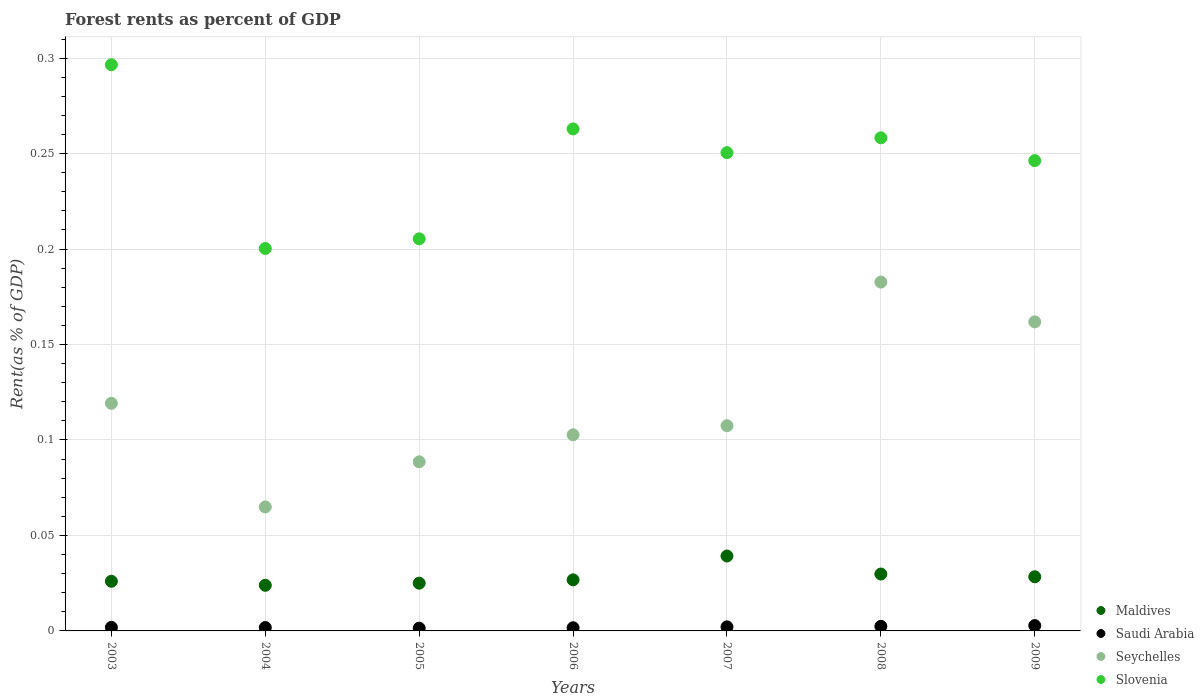How many different coloured dotlines are there?
Offer a terse response. 4. What is the forest rent in Maldives in 2009?
Give a very brief answer. 0.03. Across all years, what is the maximum forest rent in Maldives?
Your response must be concise. 0.04. Across all years, what is the minimum forest rent in Saudi Arabia?
Ensure brevity in your answer.  0. In which year was the forest rent in Saudi Arabia maximum?
Give a very brief answer. 2009. In which year was the forest rent in Slovenia minimum?
Your answer should be compact. 2004. What is the total forest rent in Slovenia in the graph?
Ensure brevity in your answer.  1.72. What is the difference between the forest rent in Seychelles in 2003 and that in 2007?
Provide a succinct answer. 0.01. What is the difference between the forest rent in Saudi Arabia in 2003 and the forest rent in Seychelles in 2008?
Offer a very short reply. -0.18. What is the average forest rent in Seychelles per year?
Your answer should be very brief. 0.12. In the year 2009, what is the difference between the forest rent in Saudi Arabia and forest rent in Slovenia?
Offer a terse response. -0.24. What is the ratio of the forest rent in Seychelles in 2003 to that in 2006?
Offer a very short reply. 1.16. Is the forest rent in Slovenia in 2003 less than that in 2009?
Give a very brief answer. No. Is the difference between the forest rent in Saudi Arabia in 2003 and 2008 greater than the difference between the forest rent in Slovenia in 2003 and 2008?
Give a very brief answer. No. What is the difference between the highest and the second highest forest rent in Seychelles?
Your response must be concise. 0.02. What is the difference between the highest and the lowest forest rent in Seychelles?
Ensure brevity in your answer.  0.12. In how many years, is the forest rent in Seychelles greater than the average forest rent in Seychelles taken over all years?
Provide a short and direct response. 3. Is it the case that in every year, the sum of the forest rent in Seychelles and forest rent in Saudi Arabia  is greater than the sum of forest rent in Slovenia and forest rent in Maldives?
Your answer should be very brief. No. Is it the case that in every year, the sum of the forest rent in Maldives and forest rent in Seychelles  is greater than the forest rent in Slovenia?
Your answer should be very brief. No. Is the forest rent in Saudi Arabia strictly greater than the forest rent in Seychelles over the years?
Give a very brief answer. No. Is the forest rent in Slovenia strictly less than the forest rent in Seychelles over the years?
Your answer should be very brief. No. Does the graph contain grids?
Provide a succinct answer. Yes. How many legend labels are there?
Offer a very short reply. 4. What is the title of the graph?
Give a very brief answer. Forest rents as percent of GDP. Does "Middle income" appear as one of the legend labels in the graph?
Keep it short and to the point. No. What is the label or title of the Y-axis?
Give a very brief answer. Rent(as % of GDP). What is the Rent(as % of GDP) in Maldives in 2003?
Keep it short and to the point. 0.03. What is the Rent(as % of GDP) in Saudi Arabia in 2003?
Your answer should be very brief. 0. What is the Rent(as % of GDP) in Seychelles in 2003?
Make the answer very short. 0.12. What is the Rent(as % of GDP) of Slovenia in 2003?
Give a very brief answer. 0.3. What is the Rent(as % of GDP) of Maldives in 2004?
Provide a succinct answer. 0.02. What is the Rent(as % of GDP) of Saudi Arabia in 2004?
Offer a terse response. 0. What is the Rent(as % of GDP) of Seychelles in 2004?
Offer a very short reply. 0.06. What is the Rent(as % of GDP) in Slovenia in 2004?
Ensure brevity in your answer.  0.2. What is the Rent(as % of GDP) in Maldives in 2005?
Your answer should be very brief. 0.03. What is the Rent(as % of GDP) in Saudi Arabia in 2005?
Keep it short and to the point. 0. What is the Rent(as % of GDP) in Seychelles in 2005?
Offer a terse response. 0.09. What is the Rent(as % of GDP) in Slovenia in 2005?
Offer a very short reply. 0.21. What is the Rent(as % of GDP) in Maldives in 2006?
Ensure brevity in your answer.  0.03. What is the Rent(as % of GDP) of Saudi Arabia in 2006?
Provide a short and direct response. 0. What is the Rent(as % of GDP) in Seychelles in 2006?
Offer a terse response. 0.1. What is the Rent(as % of GDP) in Slovenia in 2006?
Offer a very short reply. 0.26. What is the Rent(as % of GDP) in Maldives in 2007?
Your answer should be very brief. 0.04. What is the Rent(as % of GDP) of Saudi Arabia in 2007?
Provide a short and direct response. 0. What is the Rent(as % of GDP) in Seychelles in 2007?
Provide a succinct answer. 0.11. What is the Rent(as % of GDP) in Slovenia in 2007?
Give a very brief answer. 0.25. What is the Rent(as % of GDP) in Maldives in 2008?
Offer a terse response. 0.03. What is the Rent(as % of GDP) in Saudi Arabia in 2008?
Provide a short and direct response. 0. What is the Rent(as % of GDP) of Seychelles in 2008?
Give a very brief answer. 0.18. What is the Rent(as % of GDP) in Slovenia in 2008?
Offer a very short reply. 0.26. What is the Rent(as % of GDP) of Maldives in 2009?
Make the answer very short. 0.03. What is the Rent(as % of GDP) in Saudi Arabia in 2009?
Your response must be concise. 0. What is the Rent(as % of GDP) in Seychelles in 2009?
Offer a very short reply. 0.16. What is the Rent(as % of GDP) in Slovenia in 2009?
Your answer should be very brief. 0.25. Across all years, what is the maximum Rent(as % of GDP) in Maldives?
Keep it short and to the point. 0.04. Across all years, what is the maximum Rent(as % of GDP) in Saudi Arabia?
Your answer should be compact. 0. Across all years, what is the maximum Rent(as % of GDP) of Seychelles?
Provide a succinct answer. 0.18. Across all years, what is the maximum Rent(as % of GDP) in Slovenia?
Your answer should be very brief. 0.3. Across all years, what is the minimum Rent(as % of GDP) of Maldives?
Provide a succinct answer. 0.02. Across all years, what is the minimum Rent(as % of GDP) in Saudi Arabia?
Offer a very short reply. 0. Across all years, what is the minimum Rent(as % of GDP) in Seychelles?
Your response must be concise. 0.06. Across all years, what is the minimum Rent(as % of GDP) in Slovenia?
Give a very brief answer. 0.2. What is the total Rent(as % of GDP) of Maldives in the graph?
Ensure brevity in your answer.  0.2. What is the total Rent(as % of GDP) in Saudi Arabia in the graph?
Provide a short and direct response. 0.01. What is the total Rent(as % of GDP) in Seychelles in the graph?
Make the answer very short. 0.83. What is the total Rent(as % of GDP) of Slovenia in the graph?
Provide a succinct answer. 1.72. What is the difference between the Rent(as % of GDP) of Maldives in 2003 and that in 2004?
Your response must be concise. 0. What is the difference between the Rent(as % of GDP) of Seychelles in 2003 and that in 2004?
Give a very brief answer. 0.05. What is the difference between the Rent(as % of GDP) in Slovenia in 2003 and that in 2004?
Provide a succinct answer. 0.1. What is the difference between the Rent(as % of GDP) of Maldives in 2003 and that in 2005?
Provide a succinct answer. 0. What is the difference between the Rent(as % of GDP) of Saudi Arabia in 2003 and that in 2005?
Provide a short and direct response. 0. What is the difference between the Rent(as % of GDP) of Seychelles in 2003 and that in 2005?
Offer a terse response. 0.03. What is the difference between the Rent(as % of GDP) in Slovenia in 2003 and that in 2005?
Offer a very short reply. 0.09. What is the difference between the Rent(as % of GDP) in Maldives in 2003 and that in 2006?
Give a very brief answer. -0. What is the difference between the Rent(as % of GDP) of Seychelles in 2003 and that in 2006?
Your answer should be compact. 0.02. What is the difference between the Rent(as % of GDP) in Slovenia in 2003 and that in 2006?
Provide a succinct answer. 0.03. What is the difference between the Rent(as % of GDP) of Maldives in 2003 and that in 2007?
Give a very brief answer. -0.01. What is the difference between the Rent(as % of GDP) of Saudi Arabia in 2003 and that in 2007?
Offer a very short reply. -0. What is the difference between the Rent(as % of GDP) of Seychelles in 2003 and that in 2007?
Keep it short and to the point. 0.01. What is the difference between the Rent(as % of GDP) in Slovenia in 2003 and that in 2007?
Offer a very short reply. 0.05. What is the difference between the Rent(as % of GDP) in Maldives in 2003 and that in 2008?
Provide a short and direct response. -0. What is the difference between the Rent(as % of GDP) in Saudi Arabia in 2003 and that in 2008?
Keep it short and to the point. -0. What is the difference between the Rent(as % of GDP) of Seychelles in 2003 and that in 2008?
Offer a terse response. -0.06. What is the difference between the Rent(as % of GDP) in Slovenia in 2003 and that in 2008?
Ensure brevity in your answer.  0.04. What is the difference between the Rent(as % of GDP) in Maldives in 2003 and that in 2009?
Your answer should be compact. -0. What is the difference between the Rent(as % of GDP) in Saudi Arabia in 2003 and that in 2009?
Your response must be concise. -0. What is the difference between the Rent(as % of GDP) in Seychelles in 2003 and that in 2009?
Ensure brevity in your answer.  -0.04. What is the difference between the Rent(as % of GDP) of Slovenia in 2003 and that in 2009?
Offer a very short reply. 0.05. What is the difference between the Rent(as % of GDP) in Maldives in 2004 and that in 2005?
Offer a very short reply. -0. What is the difference between the Rent(as % of GDP) in Saudi Arabia in 2004 and that in 2005?
Offer a terse response. 0. What is the difference between the Rent(as % of GDP) in Seychelles in 2004 and that in 2005?
Your response must be concise. -0.02. What is the difference between the Rent(as % of GDP) in Slovenia in 2004 and that in 2005?
Ensure brevity in your answer.  -0.01. What is the difference between the Rent(as % of GDP) in Maldives in 2004 and that in 2006?
Offer a very short reply. -0. What is the difference between the Rent(as % of GDP) in Seychelles in 2004 and that in 2006?
Provide a short and direct response. -0.04. What is the difference between the Rent(as % of GDP) in Slovenia in 2004 and that in 2006?
Make the answer very short. -0.06. What is the difference between the Rent(as % of GDP) of Maldives in 2004 and that in 2007?
Keep it short and to the point. -0.02. What is the difference between the Rent(as % of GDP) in Saudi Arabia in 2004 and that in 2007?
Your answer should be compact. -0. What is the difference between the Rent(as % of GDP) of Seychelles in 2004 and that in 2007?
Keep it short and to the point. -0.04. What is the difference between the Rent(as % of GDP) of Slovenia in 2004 and that in 2007?
Your response must be concise. -0.05. What is the difference between the Rent(as % of GDP) in Maldives in 2004 and that in 2008?
Your answer should be compact. -0.01. What is the difference between the Rent(as % of GDP) in Saudi Arabia in 2004 and that in 2008?
Give a very brief answer. -0. What is the difference between the Rent(as % of GDP) of Seychelles in 2004 and that in 2008?
Your answer should be very brief. -0.12. What is the difference between the Rent(as % of GDP) of Slovenia in 2004 and that in 2008?
Your answer should be compact. -0.06. What is the difference between the Rent(as % of GDP) of Maldives in 2004 and that in 2009?
Make the answer very short. -0. What is the difference between the Rent(as % of GDP) of Saudi Arabia in 2004 and that in 2009?
Keep it short and to the point. -0. What is the difference between the Rent(as % of GDP) of Seychelles in 2004 and that in 2009?
Provide a short and direct response. -0.1. What is the difference between the Rent(as % of GDP) in Slovenia in 2004 and that in 2009?
Your answer should be compact. -0.05. What is the difference between the Rent(as % of GDP) of Maldives in 2005 and that in 2006?
Offer a terse response. -0. What is the difference between the Rent(as % of GDP) in Saudi Arabia in 2005 and that in 2006?
Provide a short and direct response. -0. What is the difference between the Rent(as % of GDP) in Seychelles in 2005 and that in 2006?
Provide a short and direct response. -0.01. What is the difference between the Rent(as % of GDP) of Slovenia in 2005 and that in 2006?
Ensure brevity in your answer.  -0.06. What is the difference between the Rent(as % of GDP) of Maldives in 2005 and that in 2007?
Your answer should be very brief. -0.01. What is the difference between the Rent(as % of GDP) in Saudi Arabia in 2005 and that in 2007?
Give a very brief answer. -0. What is the difference between the Rent(as % of GDP) of Seychelles in 2005 and that in 2007?
Provide a succinct answer. -0.02. What is the difference between the Rent(as % of GDP) in Slovenia in 2005 and that in 2007?
Offer a very short reply. -0.05. What is the difference between the Rent(as % of GDP) of Maldives in 2005 and that in 2008?
Give a very brief answer. -0. What is the difference between the Rent(as % of GDP) of Saudi Arabia in 2005 and that in 2008?
Offer a very short reply. -0. What is the difference between the Rent(as % of GDP) in Seychelles in 2005 and that in 2008?
Offer a very short reply. -0.09. What is the difference between the Rent(as % of GDP) in Slovenia in 2005 and that in 2008?
Give a very brief answer. -0.05. What is the difference between the Rent(as % of GDP) in Maldives in 2005 and that in 2009?
Make the answer very short. -0. What is the difference between the Rent(as % of GDP) in Saudi Arabia in 2005 and that in 2009?
Offer a terse response. -0. What is the difference between the Rent(as % of GDP) in Seychelles in 2005 and that in 2009?
Your answer should be compact. -0.07. What is the difference between the Rent(as % of GDP) of Slovenia in 2005 and that in 2009?
Keep it short and to the point. -0.04. What is the difference between the Rent(as % of GDP) in Maldives in 2006 and that in 2007?
Make the answer very short. -0.01. What is the difference between the Rent(as % of GDP) of Saudi Arabia in 2006 and that in 2007?
Make the answer very short. -0. What is the difference between the Rent(as % of GDP) of Seychelles in 2006 and that in 2007?
Make the answer very short. -0. What is the difference between the Rent(as % of GDP) of Slovenia in 2006 and that in 2007?
Give a very brief answer. 0.01. What is the difference between the Rent(as % of GDP) in Maldives in 2006 and that in 2008?
Your response must be concise. -0. What is the difference between the Rent(as % of GDP) in Saudi Arabia in 2006 and that in 2008?
Provide a succinct answer. -0. What is the difference between the Rent(as % of GDP) in Seychelles in 2006 and that in 2008?
Keep it short and to the point. -0.08. What is the difference between the Rent(as % of GDP) of Slovenia in 2006 and that in 2008?
Offer a terse response. 0. What is the difference between the Rent(as % of GDP) of Maldives in 2006 and that in 2009?
Offer a very short reply. -0. What is the difference between the Rent(as % of GDP) of Saudi Arabia in 2006 and that in 2009?
Give a very brief answer. -0. What is the difference between the Rent(as % of GDP) in Seychelles in 2006 and that in 2009?
Make the answer very short. -0.06. What is the difference between the Rent(as % of GDP) in Slovenia in 2006 and that in 2009?
Offer a terse response. 0.02. What is the difference between the Rent(as % of GDP) of Maldives in 2007 and that in 2008?
Provide a short and direct response. 0.01. What is the difference between the Rent(as % of GDP) in Saudi Arabia in 2007 and that in 2008?
Your answer should be compact. -0. What is the difference between the Rent(as % of GDP) in Seychelles in 2007 and that in 2008?
Give a very brief answer. -0.08. What is the difference between the Rent(as % of GDP) of Slovenia in 2007 and that in 2008?
Provide a short and direct response. -0.01. What is the difference between the Rent(as % of GDP) in Maldives in 2007 and that in 2009?
Make the answer very short. 0.01. What is the difference between the Rent(as % of GDP) in Saudi Arabia in 2007 and that in 2009?
Ensure brevity in your answer.  -0. What is the difference between the Rent(as % of GDP) in Seychelles in 2007 and that in 2009?
Offer a very short reply. -0.05. What is the difference between the Rent(as % of GDP) of Slovenia in 2007 and that in 2009?
Provide a succinct answer. 0. What is the difference between the Rent(as % of GDP) of Maldives in 2008 and that in 2009?
Ensure brevity in your answer.  0. What is the difference between the Rent(as % of GDP) of Saudi Arabia in 2008 and that in 2009?
Provide a succinct answer. -0. What is the difference between the Rent(as % of GDP) of Seychelles in 2008 and that in 2009?
Offer a terse response. 0.02. What is the difference between the Rent(as % of GDP) in Slovenia in 2008 and that in 2009?
Your answer should be compact. 0.01. What is the difference between the Rent(as % of GDP) of Maldives in 2003 and the Rent(as % of GDP) of Saudi Arabia in 2004?
Provide a short and direct response. 0.02. What is the difference between the Rent(as % of GDP) in Maldives in 2003 and the Rent(as % of GDP) in Seychelles in 2004?
Provide a short and direct response. -0.04. What is the difference between the Rent(as % of GDP) in Maldives in 2003 and the Rent(as % of GDP) in Slovenia in 2004?
Your answer should be compact. -0.17. What is the difference between the Rent(as % of GDP) of Saudi Arabia in 2003 and the Rent(as % of GDP) of Seychelles in 2004?
Make the answer very short. -0.06. What is the difference between the Rent(as % of GDP) of Saudi Arabia in 2003 and the Rent(as % of GDP) of Slovenia in 2004?
Make the answer very short. -0.2. What is the difference between the Rent(as % of GDP) of Seychelles in 2003 and the Rent(as % of GDP) of Slovenia in 2004?
Provide a succinct answer. -0.08. What is the difference between the Rent(as % of GDP) of Maldives in 2003 and the Rent(as % of GDP) of Saudi Arabia in 2005?
Provide a short and direct response. 0.02. What is the difference between the Rent(as % of GDP) of Maldives in 2003 and the Rent(as % of GDP) of Seychelles in 2005?
Make the answer very short. -0.06. What is the difference between the Rent(as % of GDP) of Maldives in 2003 and the Rent(as % of GDP) of Slovenia in 2005?
Your response must be concise. -0.18. What is the difference between the Rent(as % of GDP) in Saudi Arabia in 2003 and the Rent(as % of GDP) in Seychelles in 2005?
Your response must be concise. -0.09. What is the difference between the Rent(as % of GDP) in Saudi Arabia in 2003 and the Rent(as % of GDP) in Slovenia in 2005?
Give a very brief answer. -0.2. What is the difference between the Rent(as % of GDP) in Seychelles in 2003 and the Rent(as % of GDP) in Slovenia in 2005?
Offer a terse response. -0.09. What is the difference between the Rent(as % of GDP) of Maldives in 2003 and the Rent(as % of GDP) of Saudi Arabia in 2006?
Make the answer very short. 0.02. What is the difference between the Rent(as % of GDP) of Maldives in 2003 and the Rent(as % of GDP) of Seychelles in 2006?
Keep it short and to the point. -0.08. What is the difference between the Rent(as % of GDP) in Maldives in 2003 and the Rent(as % of GDP) in Slovenia in 2006?
Your answer should be compact. -0.24. What is the difference between the Rent(as % of GDP) in Saudi Arabia in 2003 and the Rent(as % of GDP) in Seychelles in 2006?
Your response must be concise. -0.1. What is the difference between the Rent(as % of GDP) in Saudi Arabia in 2003 and the Rent(as % of GDP) in Slovenia in 2006?
Provide a succinct answer. -0.26. What is the difference between the Rent(as % of GDP) in Seychelles in 2003 and the Rent(as % of GDP) in Slovenia in 2006?
Make the answer very short. -0.14. What is the difference between the Rent(as % of GDP) of Maldives in 2003 and the Rent(as % of GDP) of Saudi Arabia in 2007?
Your response must be concise. 0.02. What is the difference between the Rent(as % of GDP) of Maldives in 2003 and the Rent(as % of GDP) of Seychelles in 2007?
Provide a short and direct response. -0.08. What is the difference between the Rent(as % of GDP) in Maldives in 2003 and the Rent(as % of GDP) in Slovenia in 2007?
Give a very brief answer. -0.22. What is the difference between the Rent(as % of GDP) in Saudi Arabia in 2003 and the Rent(as % of GDP) in Seychelles in 2007?
Ensure brevity in your answer.  -0.11. What is the difference between the Rent(as % of GDP) of Saudi Arabia in 2003 and the Rent(as % of GDP) of Slovenia in 2007?
Your answer should be very brief. -0.25. What is the difference between the Rent(as % of GDP) of Seychelles in 2003 and the Rent(as % of GDP) of Slovenia in 2007?
Keep it short and to the point. -0.13. What is the difference between the Rent(as % of GDP) of Maldives in 2003 and the Rent(as % of GDP) of Saudi Arabia in 2008?
Keep it short and to the point. 0.02. What is the difference between the Rent(as % of GDP) in Maldives in 2003 and the Rent(as % of GDP) in Seychelles in 2008?
Provide a succinct answer. -0.16. What is the difference between the Rent(as % of GDP) of Maldives in 2003 and the Rent(as % of GDP) of Slovenia in 2008?
Your answer should be compact. -0.23. What is the difference between the Rent(as % of GDP) of Saudi Arabia in 2003 and the Rent(as % of GDP) of Seychelles in 2008?
Give a very brief answer. -0.18. What is the difference between the Rent(as % of GDP) of Saudi Arabia in 2003 and the Rent(as % of GDP) of Slovenia in 2008?
Make the answer very short. -0.26. What is the difference between the Rent(as % of GDP) of Seychelles in 2003 and the Rent(as % of GDP) of Slovenia in 2008?
Your answer should be very brief. -0.14. What is the difference between the Rent(as % of GDP) of Maldives in 2003 and the Rent(as % of GDP) of Saudi Arabia in 2009?
Keep it short and to the point. 0.02. What is the difference between the Rent(as % of GDP) of Maldives in 2003 and the Rent(as % of GDP) of Seychelles in 2009?
Your answer should be very brief. -0.14. What is the difference between the Rent(as % of GDP) of Maldives in 2003 and the Rent(as % of GDP) of Slovenia in 2009?
Keep it short and to the point. -0.22. What is the difference between the Rent(as % of GDP) in Saudi Arabia in 2003 and the Rent(as % of GDP) in Seychelles in 2009?
Keep it short and to the point. -0.16. What is the difference between the Rent(as % of GDP) of Saudi Arabia in 2003 and the Rent(as % of GDP) of Slovenia in 2009?
Give a very brief answer. -0.24. What is the difference between the Rent(as % of GDP) of Seychelles in 2003 and the Rent(as % of GDP) of Slovenia in 2009?
Provide a succinct answer. -0.13. What is the difference between the Rent(as % of GDP) of Maldives in 2004 and the Rent(as % of GDP) of Saudi Arabia in 2005?
Your answer should be compact. 0.02. What is the difference between the Rent(as % of GDP) in Maldives in 2004 and the Rent(as % of GDP) in Seychelles in 2005?
Keep it short and to the point. -0.06. What is the difference between the Rent(as % of GDP) in Maldives in 2004 and the Rent(as % of GDP) in Slovenia in 2005?
Offer a terse response. -0.18. What is the difference between the Rent(as % of GDP) in Saudi Arabia in 2004 and the Rent(as % of GDP) in Seychelles in 2005?
Ensure brevity in your answer.  -0.09. What is the difference between the Rent(as % of GDP) of Saudi Arabia in 2004 and the Rent(as % of GDP) of Slovenia in 2005?
Give a very brief answer. -0.2. What is the difference between the Rent(as % of GDP) in Seychelles in 2004 and the Rent(as % of GDP) in Slovenia in 2005?
Your answer should be compact. -0.14. What is the difference between the Rent(as % of GDP) in Maldives in 2004 and the Rent(as % of GDP) in Saudi Arabia in 2006?
Your answer should be very brief. 0.02. What is the difference between the Rent(as % of GDP) in Maldives in 2004 and the Rent(as % of GDP) in Seychelles in 2006?
Provide a short and direct response. -0.08. What is the difference between the Rent(as % of GDP) in Maldives in 2004 and the Rent(as % of GDP) in Slovenia in 2006?
Make the answer very short. -0.24. What is the difference between the Rent(as % of GDP) of Saudi Arabia in 2004 and the Rent(as % of GDP) of Seychelles in 2006?
Your answer should be very brief. -0.1. What is the difference between the Rent(as % of GDP) of Saudi Arabia in 2004 and the Rent(as % of GDP) of Slovenia in 2006?
Offer a very short reply. -0.26. What is the difference between the Rent(as % of GDP) of Seychelles in 2004 and the Rent(as % of GDP) of Slovenia in 2006?
Offer a terse response. -0.2. What is the difference between the Rent(as % of GDP) in Maldives in 2004 and the Rent(as % of GDP) in Saudi Arabia in 2007?
Keep it short and to the point. 0.02. What is the difference between the Rent(as % of GDP) of Maldives in 2004 and the Rent(as % of GDP) of Seychelles in 2007?
Give a very brief answer. -0.08. What is the difference between the Rent(as % of GDP) in Maldives in 2004 and the Rent(as % of GDP) in Slovenia in 2007?
Your answer should be very brief. -0.23. What is the difference between the Rent(as % of GDP) in Saudi Arabia in 2004 and the Rent(as % of GDP) in Seychelles in 2007?
Your answer should be very brief. -0.11. What is the difference between the Rent(as % of GDP) of Saudi Arabia in 2004 and the Rent(as % of GDP) of Slovenia in 2007?
Keep it short and to the point. -0.25. What is the difference between the Rent(as % of GDP) of Seychelles in 2004 and the Rent(as % of GDP) of Slovenia in 2007?
Offer a terse response. -0.19. What is the difference between the Rent(as % of GDP) in Maldives in 2004 and the Rent(as % of GDP) in Saudi Arabia in 2008?
Your answer should be compact. 0.02. What is the difference between the Rent(as % of GDP) of Maldives in 2004 and the Rent(as % of GDP) of Seychelles in 2008?
Offer a very short reply. -0.16. What is the difference between the Rent(as % of GDP) of Maldives in 2004 and the Rent(as % of GDP) of Slovenia in 2008?
Offer a terse response. -0.23. What is the difference between the Rent(as % of GDP) in Saudi Arabia in 2004 and the Rent(as % of GDP) in Seychelles in 2008?
Offer a very short reply. -0.18. What is the difference between the Rent(as % of GDP) of Saudi Arabia in 2004 and the Rent(as % of GDP) of Slovenia in 2008?
Ensure brevity in your answer.  -0.26. What is the difference between the Rent(as % of GDP) in Seychelles in 2004 and the Rent(as % of GDP) in Slovenia in 2008?
Your answer should be compact. -0.19. What is the difference between the Rent(as % of GDP) of Maldives in 2004 and the Rent(as % of GDP) of Saudi Arabia in 2009?
Offer a very short reply. 0.02. What is the difference between the Rent(as % of GDP) in Maldives in 2004 and the Rent(as % of GDP) in Seychelles in 2009?
Ensure brevity in your answer.  -0.14. What is the difference between the Rent(as % of GDP) of Maldives in 2004 and the Rent(as % of GDP) of Slovenia in 2009?
Make the answer very short. -0.22. What is the difference between the Rent(as % of GDP) of Saudi Arabia in 2004 and the Rent(as % of GDP) of Seychelles in 2009?
Give a very brief answer. -0.16. What is the difference between the Rent(as % of GDP) in Saudi Arabia in 2004 and the Rent(as % of GDP) in Slovenia in 2009?
Keep it short and to the point. -0.24. What is the difference between the Rent(as % of GDP) in Seychelles in 2004 and the Rent(as % of GDP) in Slovenia in 2009?
Keep it short and to the point. -0.18. What is the difference between the Rent(as % of GDP) in Maldives in 2005 and the Rent(as % of GDP) in Saudi Arabia in 2006?
Your answer should be very brief. 0.02. What is the difference between the Rent(as % of GDP) in Maldives in 2005 and the Rent(as % of GDP) in Seychelles in 2006?
Give a very brief answer. -0.08. What is the difference between the Rent(as % of GDP) of Maldives in 2005 and the Rent(as % of GDP) of Slovenia in 2006?
Provide a short and direct response. -0.24. What is the difference between the Rent(as % of GDP) in Saudi Arabia in 2005 and the Rent(as % of GDP) in Seychelles in 2006?
Provide a succinct answer. -0.1. What is the difference between the Rent(as % of GDP) in Saudi Arabia in 2005 and the Rent(as % of GDP) in Slovenia in 2006?
Your response must be concise. -0.26. What is the difference between the Rent(as % of GDP) of Seychelles in 2005 and the Rent(as % of GDP) of Slovenia in 2006?
Your answer should be very brief. -0.17. What is the difference between the Rent(as % of GDP) in Maldives in 2005 and the Rent(as % of GDP) in Saudi Arabia in 2007?
Your response must be concise. 0.02. What is the difference between the Rent(as % of GDP) in Maldives in 2005 and the Rent(as % of GDP) in Seychelles in 2007?
Give a very brief answer. -0.08. What is the difference between the Rent(as % of GDP) of Maldives in 2005 and the Rent(as % of GDP) of Slovenia in 2007?
Your answer should be compact. -0.23. What is the difference between the Rent(as % of GDP) of Saudi Arabia in 2005 and the Rent(as % of GDP) of Seychelles in 2007?
Offer a very short reply. -0.11. What is the difference between the Rent(as % of GDP) of Saudi Arabia in 2005 and the Rent(as % of GDP) of Slovenia in 2007?
Provide a short and direct response. -0.25. What is the difference between the Rent(as % of GDP) in Seychelles in 2005 and the Rent(as % of GDP) in Slovenia in 2007?
Provide a short and direct response. -0.16. What is the difference between the Rent(as % of GDP) of Maldives in 2005 and the Rent(as % of GDP) of Saudi Arabia in 2008?
Your answer should be compact. 0.02. What is the difference between the Rent(as % of GDP) in Maldives in 2005 and the Rent(as % of GDP) in Seychelles in 2008?
Give a very brief answer. -0.16. What is the difference between the Rent(as % of GDP) in Maldives in 2005 and the Rent(as % of GDP) in Slovenia in 2008?
Ensure brevity in your answer.  -0.23. What is the difference between the Rent(as % of GDP) in Saudi Arabia in 2005 and the Rent(as % of GDP) in Seychelles in 2008?
Offer a terse response. -0.18. What is the difference between the Rent(as % of GDP) of Saudi Arabia in 2005 and the Rent(as % of GDP) of Slovenia in 2008?
Your response must be concise. -0.26. What is the difference between the Rent(as % of GDP) in Seychelles in 2005 and the Rent(as % of GDP) in Slovenia in 2008?
Ensure brevity in your answer.  -0.17. What is the difference between the Rent(as % of GDP) of Maldives in 2005 and the Rent(as % of GDP) of Saudi Arabia in 2009?
Give a very brief answer. 0.02. What is the difference between the Rent(as % of GDP) of Maldives in 2005 and the Rent(as % of GDP) of Seychelles in 2009?
Offer a terse response. -0.14. What is the difference between the Rent(as % of GDP) in Maldives in 2005 and the Rent(as % of GDP) in Slovenia in 2009?
Your answer should be very brief. -0.22. What is the difference between the Rent(as % of GDP) in Saudi Arabia in 2005 and the Rent(as % of GDP) in Seychelles in 2009?
Your answer should be compact. -0.16. What is the difference between the Rent(as % of GDP) of Saudi Arabia in 2005 and the Rent(as % of GDP) of Slovenia in 2009?
Offer a terse response. -0.24. What is the difference between the Rent(as % of GDP) of Seychelles in 2005 and the Rent(as % of GDP) of Slovenia in 2009?
Give a very brief answer. -0.16. What is the difference between the Rent(as % of GDP) in Maldives in 2006 and the Rent(as % of GDP) in Saudi Arabia in 2007?
Provide a short and direct response. 0.02. What is the difference between the Rent(as % of GDP) in Maldives in 2006 and the Rent(as % of GDP) in Seychelles in 2007?
Keep it short and to the point. -0.08. What is the difference between the Rent(as % of GDP) of Maldives in 2006 and the Rent(as % of GDP) of Slovenia in 2007?
Offer a terse response. -0.22. What is the difference between the Rent(as % of GDP) of Saudi Arabia in 2006 and the Rent(as % of GDP) of Seychelles in 2007?
Your answer should be very brief. -0.11. What is the difference between the Rent(as % of GDP) in Saudi Arabia in 2006 and the Rent(as % of GDP) in Slovenia in 2007?
Your answer should be compact. -0.25. What is the difference between the Rent(as % of GDP) in Seychelles in 2006 and the Rent(as % of GDP) in Slovenia in 2007?
Ensure brevity in your answer.  -0.15. What is the difference between the Rent(as % of GDP) of Maldives in 2006 and the Rent(as % of GDP) of Saudi Arabia in 2008?
Ensure brevity in your answer.  0.02. What is the difference between the Rent(as % of GDP) of Maldives in 2006 and the Rent(as % of GDP) of Seychelles in 2008?
Your answer should be compact. -0.16. What is the difference between the Rent(as % of GDP) in Maldives in 2006 and the Rent(as % of GDP) in Slovenia in 2008?
Keep it short and to the point. -0.23. What is the difference between the Rent(as % of GDP) of Saudi Arabia in 2006 and the Rent(as % of GDP) of Seychelles in 2008?
Give a very brief answer. -0.18. What is the difference between the Rent(as % of GDP) of Saudi Arabia in 2006 and the Rent(as % of GDP) of Slovenia in 2008?
Keep it short and to the point. -0.26. What is the difference between the Rent(as % of GDP) in Seychelles in 2006 and the Rent(as % of GDP) in Slovenia in 2008?
Your answer should be compact. -0.16. What is the difference between the Rent(as % of GDP) in Maldives in 2006 and the Rent(as % of GDP) in Saudi Arabia in 2009?
Provide a short and direct response. 0.02. What is the difference between the Rent(as % of GDP) of Maldives in 2006 and the Rent(as % of GDP) of Seychelles in 2009?
Offer a terse response. -0.14. What is the difference between the Rent(as % of GDP) of Maldives in 2006 and the Rent(as % of GDP) of Slovenia in 2009?
Your response must be concise. -0.22. What is the difference between the Rent(as % of GDP) of Saudi Arabia in 2006 and the Rent(as % of GDP) of Seychelles in 2009?
Give a very brief answer. -0.16. What is the difference between the Rent(as % of GDP) of Saudi Arabia in 2006 and the Rent(as % of GDP) of Slovenia in 2009?
Give a very brief answer. -0.24. What is the difference between the Rent(as % of GDP) of Seychelles in 2006 and the Rent(as % of GDP) of Slovenia in 2009?
Keep it short and to the point. -0.14. What is the difference between the Rent(as % of GDP) of Maldives in 2007 and the Rent(as % of GDP) of Saudi Arabia in 2008?
Your answer should be very brief. 0.04. What is the difference between the Rent(as % of GDP) of Maldives in 2007 and the Rent(as % of GDP) of Seychelles in 2008?
Your answer should be compact. -0.14. What is the difference between the Rent(as % of GDP) in Maldives in 2007 and the Rent(as % of GDP) in Slovenia in 2008?
Your answer should be compact. -0.22. What is the difference between the Rent(as % of GDP) in Saudi Arabia in 2007 and the Rent(as % of GDP) in Seychelles in 2008?
Your response must be concise. -0.18. What is the difference between the Rent(as % of GDP) of Saudi Arabia in 2007 and the Rent(as % of GDP) of Slovenia in 2008?
Your response must be concise. -0.26. What is the difference between the Rent(as % of GDP) in Seychelles in 2007 and the Rent(as % of GDP) in Slovenia in 2008?
Make the answer very short. -0.15. What is the difference between the Rent(as % of GDP) in Maldives in 2007 and the Rent(as % of GDP) in Saudi Arabia in 2009?
Keep it short and to the point. 0.04. What is the difference between the Rent(as % of GDP) of Maldives in 2007 and the Rent(as % of GDP) of Seychelles in 2009?
Your answer should be very brief. -0.12. What is the difference between the Rent(as % of GDP) of Maldives in 2007 and the Rent(as % of GDP) of Slovenia in 2009?
Give a very brief answer. -0.21. What is the difference between the Rent(as % of GDP) in Saudi Arabia in 2007 and the Rent(as % of GDP) in Seychelles in 2009?
Your answer should be compact. -0.16. What is the difference between the Rent(as % of GDP) in Saudi Arabia in 2007 and the Rent(as % of GDP) in Slovenia in 2009?
Your response must be concise. -0.24. What is the difference between the Rent(as % of GDP) of Seychelles in 2007 and the Rent(as % of GDP) of Slovenia in 2009?
Your answer should be very brief. -0.14. What is the difference between the Rent(as % of GDP) in Maldives in 2008 and the Rent(as % of GDP) in Saudi Arabia in 2009?
Provide a short and direct response. 0.03. What is the difference between the Rent(as % of GDP) of Maldives in 2008 and the Rent(as % of GDP) of Seychelles in 2009?
Make the answer very short. -0.13. What is the difference between the Rent(as % of GDP) of Maldives in 2008 and the Rent(as % of GDP) of Slovenia in 2009?
Your answer should be very brief. -0.22. What is the difference between the Rent(as % of GDP) of Saudi Arabia in 2008 and the Rent(as % of GDP) of Seychelles in 2009?
Your answer should be very brief. -0.16. What is the difference between the Rent(as % of GDP) of Saudi Arabia in 2008 and the Rent(as % of GDP) of Slovenia in 2009?
Your answer should be compact. -0.24. What is the difference between the Rent(as % of GDP) in Seychelles in 2008 and the Rent(as % of GDP) in Slovenia in 2009?
Your answer should be very brief. -0.06. What is the average Rent(as % of GDP) of Maldives per year?
Your answer should be very brief. 0.03. What is the average Rent(as % of GDP) in Saudi Arabia per year?
Provide a short and direct response. 0. What is the average Rent(as % of GDP) in Seychelles per year?
Provide a succinct answer. 0.12. What is the average Rent(as % of GDP) in Slovenia per year?
Provide a short and direct response. 0.25. In the year 2003, what is the difference between the Rent(as % of GDP) of Maldives and Rent(as % of GDP) of Saudi Arabia?
Ensure brevity in your answer.  0.02. In the year 2003, what is the difference between the Rent(as % of GDP) in Maldives and Rent(as % of GDP) in Seychelles?
Your response must be concise. -0.09. In the year 2003, what is the difference between the Rent(as % of GDP) of Maldives and Rent(as % of GDP) of Slovenia?
Your answer should be compact. -0.27. In the year 2003, what is the difference between the Rent(as % of GDP) of Saudi Arabia and Rent(as % of GDP) of Seychelles?
Make the answer very short. -0.12. In the year 2003, what is the difference between the Rent(as % of GDP) of Saudi Arabia and Rent(as % of GDP) of Slovenia?
Keep it short and to the point. -0.29. In the year 2003, what is the difference between the Rent(as % of GDP) in Seychelles and Rent(as % of GDP) in Slovenia?
Your answer should be compact. -0.18. In the year 2004, what is the difference between the Rent(as % of GDP) of Maldives and Rent(as % of GDP) of Saudi Arabia?
Ensure brevity in your answer.  0.02. In the year 2004, what is the difference between the Rent(as % of GDP) of Maldives and Rent(as % of GDP) of Seychelles?
Offer a terse response. -0.04. In the year 2004, what is the difference between the Rent(as % of GDP) of Maldives and Rent(as % of GDP) of Slovenia?
Your answer should be compact. -0.18. In the year 2004, what is the difference between the Rent(as % of GDP) of Saudi Arabia and Rent(as % of GDP) of Seychelles?
Offer a very short reply. -0.06. In the year 2004, what is the difference between the Rent(as % of GDP) of Saudi Arabia and Rent(as % of GDP) of Slovenia?
Offer a very short reply. -0.2. In the year 2004, what is the difference between the Rent(as % of GDP) in Seychelles and Rent(as % of GDP) in Slovenia?
Offer a very short reply. -0.14. In the year 2005, what is the difference between the Rent(as % of GDP) in Maldives and Rent(as % of GDP) in Saudi Arabia?
Your answer should be compact. 0.02. In the year 2005, what is the difference between the Rent(as % of GDP) of Maldives and Rent(as % of GDP) of Seychelles?
Offer a very short reply. -0.06. In the year 2005, what is the difference between the Rent(as % of GDP) in Maldives and Rent(as % of GDP) in Slovenia?
Offer a very short reply. -0.18. In the year 2005, what is the difference between the Rent(as % of GDP) of Saudi Arabia and Rent(as % of GDP) of Seychelles?
Keep it short and to the point. -0.09. In the year 2005, what is the difference between the Rent(as % of GDP) of Saudi Arabia and Rent(as % of GDP) of Slovenia?
Your answer should be very brief. -0.2. In the year 2005, what is the difference between the Rent(as % of GDP) in Seychelles and Rent(as % of GDP) in Slovenia?
Ensure brevity in your answer.  -0.12. In the year 2006, what is the difference between the Rent(as % of GDP) in Maldives and Rent(as % of GDP) in Saudi Arabia?
Your answer should be compact. 0.03. In the year 2006, what is the difference between the Rent(as % of GDP) in Maldives and Rent(as % of GDP) in Seychelles?
Ensure brevity in your answer.  -0.08. In the year 2006, what is the difference between the Rent(as % of GDP) in Maldives and Rent(as % of GDP) in Slovenia?
Give a very brief answer. -0.24. In the year 2006, what is the difference between the Rent(as % of GDP) in Saudi Arabia and Rent(as % of GDP) in Seychelles?
Provide a succinct answer. -0.1. In the year 2006, what is the difference between the Rent(as % of GDP) in Saudi Arabia and Rent(as % of GDP) in Slovenia?
Your answer should be compact. -0.26. In the year 2006, what is the difference between the Rent(as % of GDP) of Seychelles and Rent(as % of GDP) of Slovenia?
Ensure brevity in your answer.  -0.16. In the year 2007, what is the difference between the Rent(as % of GDP) of Maldives and Rent(as % of GDP) of Saudi Arabia?
Your answer should be very brief. 0.04. In the year 2007, what is the difference between the Rent(as % of GDP) in Maldives and Rent(as % of GDP) in Seychelles?
Ensure brevity in your answer.  -0.07. In the year 2007, what is the difference between the Rent(as % of GDP) of Maldives and Rent(as % of GDP) of Slovenia?
Offer a very short reply. -0.21. In the year 2007, what is the difference between the Rent(as % of GDP) in Saudi Arabia and Rent(as % of GDP) in Seychelles?
Provide a short and direct response. -0.11. In the year 2007, what is the difference between the Rent(as % of GDP) in Saudi Arabia and Rent(as % of GDP) in Slovenia?
Offer a terse response. -0.25. In the year 2007, what is the difference between the Rent(as % of GDP) of Seychelles and Rent(as % of GDP) of Slovenia?
Your answer should be compact. -0.14. In the year 2008, what is the difference between the Rent(as % of GDP) of Maldives and Rent(as % of GDP) of Saudi Arabia?
Give a very brief answer. 0.03. In the year 2008, what is the difference between the Rent(as % of GDP) of Maldives and Rent(as % of GDP) of Seychelles?
Make the answer very short. -0.15. In the year 2008, what is the difference between the Rent(as % of GDP) of Maldives and Rent(as % of GDP) of Slovenia?
Ensure brevity in your answer.  -0.23. In the year 2008, what is the difference between the Rent(as % of GDP) of Saudi Arabia and Rent(as % of GDP) of Seychelles?
Offer a terse response. -0.18. In the year 2008, what is the difference between the Rent(as % of GDP) in Saudi Arabia and Rent(as % of GDP) in Slovenia?
Give a very brief answer. -0.26. In the year 2008, what is the difference between the Rent(as % of GDP) of Seychelles and Rent(as % of GDP) of Slovenia?
Ensure brevity in your answer.  -0.08. In the year 2009, what is the difference between the Rent(as % of GDP) in Maldives and Rent(as % of GDP) in Saudi Arabia?
Provide a short and direct response. 0.03. In the year 2009, what is the difference between the Rent(as % of GDP) of Maldives and Rent(as % of GDP) of Seychelles?
Make the answer very short. -0.13. In the year 2009, what is the difference between the Rent(as % of GDP) in Maldives and Rent(as % of GDP) in Slovenia?
Your answer should be compact. -0.22. In the year 2009, what is the difference between the Rent(as % of GDP) of Saudi Arabia and Rent(as % of GDP) of Seychelles?
Provide a succinct answer. -0.16. In the year 2009, what is the difference between the Rent(as % of GDP) in Saudi Arabia and Rent(as % of GDP) in Slovenia?
Provide a succinct answer. -0.24. In the year 2009, what is the difference between the Rent(as % of GDP) in Seychelles and Rent(as % of GDP) in Slovenia?
Your response must be concise. -0.08. What is the ratio of the Rent(as % of GDP) of Maldives in 2003 to that in 2004?
Provide a succinct answer. 1.09. What is the ratio of the Rent(as % of GDP) in Saudi Arabia in 2003 to that in 2004?
Your answer should be compact. 1.05. What is the ratio of the Rent(as % of GDP) in Seychelles in 2003 to that in 2004?
Your answer should be compact. 1.84. What is the ratio of the Rent(as % of GDP) of Slovenia in 2003 to that in 2004?
Ensure brevity in your answer.  1.48. What is the ratio of the Rent(as % of GDP) in Maldives in 2003 to that in 2005?
Your response must be concise. 1.04. What is the ratio of the Rent(as % of GDP) of Saudi Arabia in 2003 to that in 2005?
Make the answer very short. 1.29. What is the ratio of the Rent(as % of GDP) in Seychelles in 2003 to that in 2005?
Your answer should be compact. 1.35. What is the ratio of the Rent(as % of GDP) of Slovenia in 2003 to that in 2005?
Your answer should be compact. 1.44. What is the ratio of the Rent(as % of GDP) of Maldives in 2003 to that in 2006?
Provide a short and direct response. 0.97. What is the ratio of the Rent(as % of GDP) in Saudi Arabia in 2003 to that in 2006?
Your answer should be compact. 1.13. What is the ratio of the Rent(as % of GDP) of Seychelles in 2003 to that in 2006?
Offer a terse response. 1.16. What is the ratio of the Rent(as % of GDP) in Slovenia in 2003 to that in 2006?
Make the answer very short. 1.13. What is the ratio of the Rent(as % of GDP) in Maldives in 2003 to that in 2007?
Offer a terse response. 0.66. What is the ratio of the Rent(as % of GDP) of Saudi Arabia in 2003 to that in 2007?
Give a very brief answer. 0.88. What is the ratio of the Rent(as % of GDP) of Seychelles in 2003 to that in 2007?
Your answer should be very brief. 1.11. What is the ratio of the Rent(as % of GDP) of Slovenia in 2003 to that in 2007?
Provide a short and direct response. 1.18. What is the ratio of the Rent(as % of GDP) in Maldives in 2003 to that in 2008?
Keep it short and to the point. 0.87. What is the ratio of the Rent(as % of GDP) in Saudi Arabia in 2003 to that in 2008?
Make the answer very short. 0.78. What is the ratio of the Rent(as % of GDP) of Seychelles in 2003 to that in 2008?
Your answer should be very brief. 0.65. What is the ratio of the Rent(as % of GDP) in Slovenia in 2003 to that in 2008?
Offer a very short reply. 1.15. What is the ratio of the Rent(as % of GDP) in Maldives in 2003 to that in 2009?
Give a very brief answer. 0.92. What is the ratio of the Rent(as % of GDP) in Saudi Arabia in 2003 to that in 2009?
Offer a very short reply. 0.67. What is the ratio of the Rent(as % of GDP) in Seychelles in 2003 to that in 2009?
Provide a short and direct response. 0.74. What is the ratio of the Rent(as % of GDP) of Slovenia in 2003 to that in 2009?
Keep it short and to the point. 1.2. What is the ratio of the Rent(as % of GDP) of Maldives in 2004 to that in 2005?
Offer a terse response. 0.96. What is the ratio of the Rent(as % of GDP) of Saudi Arabia in 2004 to that in 2005?
Ensure brevity in your answer.  1.23. What is the ratio of the Rent(as % of GDP) in Seychelles in 2004 to that in 2005?
Your answer should be very brief. 0.73. What is the ratio of the Rent(as % of GDP) of Slovenia in 2004 to that in 2005?
Give a very brief answer. 0.98. What is the ratio of the Rent(as % of GDP) of Maldives in 2004 to that in 2006?
Make the answer very short. 0.89. What is the ratio of the Rent(as % of GDP) of Saudi Arabia in 2004 to that in 2006?
Give a very brief answer. 1.07. What is the ratio of the Rent(as % of GDP) of Seychelles in 2004 to that in 2006?
Provide a succinct answer. 0.63. What is the ratio of the Rent(as % of GDP) in Slovenia in 2004 to that in 2006?
Provide a succinct answer. 0.76. What is the ratio of the Rent(as % of GDP) of Maldives in 2004 to that in 2007?
Offer a very short reply. 0.61. What is the ratio of the Rent(as % of GDP) of Saudi Arabia in 2004 to that in 2007?
Keep it short and to the point. 0.84. What is the ratio of the Rent(as % of GDP) of Seychelles in 2004 to that in 2007?
Offer a very short reply. 0.6. What is the ratio of the Rent(as % of GDP) of Slovenia in 2004 to that in 2007?
Make the answer very short. 0.8. What is the ratio of the Rent(as % of GDP) in Maldives in 2004 to that in 2008?
Your answer should be compact. 0.8. What is the ratio of the Rent(as % of GDP) of Saudi Arabia in 2004 to that in 2008?
Give a very brief answer. 0.74. What is the ratio of the Rent(as % of GDP) in Seychelles in 2004 to that in 2008?
Provide a short and direct response. 0.36. What is the ratio of the Rent(as % of GDP) in Slovenia in 2004 to that in 2008?
Provide a succinct answer. 0.78. What is the ratio of the Rent(as % of GDP) of Maldives in 2004 to that in 2009?
Keep it short and to the point. 0.84. What is the ratio of the Rent(as % of GDP) in Saudi Arabia in 2004 to that in 2009?
Ensure brevity in your answer.  0.64. What is the ratio of the Rent(as % of GDP) in Seychelles in 2004 to that in 2009?
Offer a very short reply. 0.4. What is the ratio of the Rent(as % of GDP) of Slovenia in 2004 to that in 2009?
Provide a succinct answer. 0.81. What is the ratio of the Rent(as % of GDP) in Maldives in 2005 to that in 2006?
Make the answer very short. 0.94. What is the ratio of the Rent(as % of GDP) in Saudi Arabia in 2005 to that in 2006?
Offer a very short reply. 0.87. What is the ratio of the Rent(as % of GDP) in Seychelles in 2005 to that in 2006?
Offer a very short reply. 0.86. What is the ratio of the Rent(as % of GDP) of Slovenia in 2005 to that in 2006?
Your answer should be compact. 0.78. What is the ratio of the Rent(as % of GDP) of Maldives in 2005 to that in 2007?
Your answer should be compact. 0.64. What is the ratio of the Rent(as % of GDP) of Saudi Arabia in 2005 to that in 2007?
Give a very brief answer. 0.68. What is the ratio of the Rent(as % of GDP) in Seychelles in 2005 to that in 2007?
Ensure brevity in your answer.  0.82. What is the ratio of the Rent(as % of GDP) of Slovenia in 2005 to that in 2007?
Your response must be concise. 0.82. What is the ratio of the Rent(as % of GDP) of Maldives in 2005 to that in 2008?
Your response must be concise. 0.84. What is the ratio of the Rent(as % of GDP) of Saudi Arabia in 2005 to that in 2008?
Ensure brevity in your answer.  0.6. What is the ratio of the Rent(as % of GDP) in Seychelles in 2005 to that in 2008?
Your response must be concise. 0.48. What is the ratio of the Rent(as % of GDP) in Slovenia in 2005 to that in 2008?
Provide a succinct answer. 0.8. What is the ratio of the Rent(as % of GDP) of Maldives in 2005 to that in 2009?
Make the answer very short. 0.88. What is the ratio of the Rent(as % of GDP) in Saudi Arabia in 2005 to that in 2009?
Keep it short and to the point. 0.51. What is the ratio of the Rent(as % of GDP) of Seychelles in 2005 to that in 2009?
Provide a short and direct response. 0.55. What is the ratio of the Rent(as % of GDP) of Slovenia in 2005 to that in 2009?
Keep it short and to the point. 0.83. What is the ratio of the Rent(as % of GDP) of Maldives in 2006 to that in 2007?
Provide a short and direct response. 0.68. What is the ratio of the Rent(as % of GDP) in Saudi Arabia in 2006 to that in 2007?
Your response must be concise. 0.78. What is the ratio of the Rent(as % of GDP) in Seychelles in 2006 to that in 2007?
Give a very brief answer. 0.96. What is the ratio of the Rent(as % of GDP) of Slovenia in 2006 to that in 2007?
Your answer should be very brief. 1.05. What is the ratio of the Rent(as % of GDP) in Maldives in 2006 to that in 2008?
Your answer should be very brief. 0.9. What is the ratio of the Rent(as % of GDP) of Saudi Arabia in 2006 to that in 2008?
Make the answer very short. 0.69. What is the ratio of the Rent(as % of GDP) in Seychelles in 2006 to that in 2008?
Provide a succinct answer. 0.56. What is the ratio of the Rent(as % of GDP) of Maldives in 2006 to that in 2009?
Give a very brief answer. 0.94. What is the ratio of the Rent(as % of GDP) in Saudi Arabia in 2006 to that in 2009?
Offer a terse response. 0.59. What is the ratio of the Rent(as % of GDP) in Seychelles in 2006 to that in 2009?
Your answer should be compact. 0.63. What is the ratio of the Rent(as % of GDP) in Slovenia in 2006 to that in 2009?
Ensure brevity in your answer.  1.07. What is the ratio of the Rent(as % of GDP) of Maldives in 2007 to that in 2008?
Give a very brief answer. 1.32. What is the ratio of the Rent(as % of GDP) in Saudi Arabia in 2007 to that in 2008?
Provide a short and direct response. 0.89. What is the ratio of the Rent(as % of GDP) in Seychelles in 2007 to that in 2008?
Ensure brevity in your answer.  0.59. What is the ratio of the Rent(as % of GDP) in Slovenia in 2007 to that in 2008?
Ensure brevity in your answer.  0.97. What is the ratio of the Rent(as % of GDP) of Maldives in 2007 to that in 2009?
Ensure brevity in your answer.  1.38. What is the ratio of the Rent(as % of GDP) in Saudi Arabia in 2007 to that in 2009?
Make the answer very short. 0.76. What is the ratio of the Rent(as % of GDP) of Seychelles in 2007 to that in 2009?
Give a very brief answer. 0.66. What is the ratio of the Rent(as % of GDP) in Slovenia in 2007 to that in 2009?
Your answer should be compact. 1.02. What is the ratio of the Rent(as % of GDP) in Maldives in 2008 to that in 2009?
Your response must be concise. 1.05. What is the ratio of the Rent(as % of GDP) of Saudi Arabia in 2008 to that in 2009?
Give a very brief answer. 0.86. What is the ratio of the Rent(as % of GDP) of Seychelles in 2008 to that in 2009?
Make the answer very short. 1.13. What is the ratio of the Rent(as % of GDP) in Slovenia in 2008 to that in 2009?
Give a very brief answer. 1.05. What is the difference between the highest and the second highest Rent(as % of GDP) of Maldives?
Give a very brief answer. 0.01. What is the difference between the highest and the second highest Rent(as % of GDP) of Seychelles?
Offer a terse response. 0.02. What is the difference between the highest and the second highest Rent(as % of GDP) of Slovenia?
Offer a terse response. 0.03. What is the difference between the highest and the lowest Rent(as % of GDP) in Maldives?
Make the answer very short. 0.02. What is the difference between the highest and the lowest Rent(as % of GDP) of Saudi Arabia?
Give a very brief answer. 0. What is the difference between the highest and the lowest Rent(as % of GDP) of Seychelles?
Ensure brevity in your answer.  0.12. What is the difference between the highest and the lowest Rent(as % of GDP) of Slovenia?
Your answer should be very brief. 0.1. 